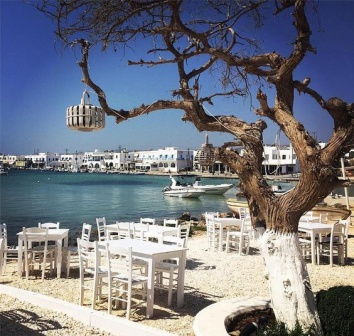Could this be a good spot for a writer looking for inspiration? Why or why not? Absolutely, this could be an excellent spot for a writer seeking inspiration. The tranquil and picturesque harbor, the rhythmic sound of the waves, and the gentle rustle of the leaves in the breeze offer a serene environment conducive to creativity. The blend of natural beauty and the bustling yet relaxed ambiance of the restaurant can ignite the imagination, provide a rich tapestry of sensory experiences, and prompt a plethora of ideas. Whether it's for writing poetry, a novel, or reflective essays, this setting has the perfect blend of calm and vibrancy to spark inspiration. What scenes might a writer describe if they spent a day here? A writer spending a day here might describe the mesmerizing view as the sun rises, casting a golden hue over the turquoise waters of the harbor. They might pen the bustling activity of early morning fishermen returning with their fresh catches, the laughter of children playing by the water, or the aroma of freshly brewed coffee and baked pastries wafting through the air as the restaurant prepares for its first customers. As the day progresses, the writer could capture the lively ambiance of lunchtime, with patrons engaging in animated conversations and savoring delicious meals under the shade of the tree. The afternoon might bring a calm, reflective scene, with fewer diners and a gentle breeze flowing through. As evening descends, they could explore the exquisite interplay of lights on the water, the soft melodies of live music, and the shared joy of people dining under a starlit sky, creating a profoundly touching narrative of a place where every moment feels magical. 